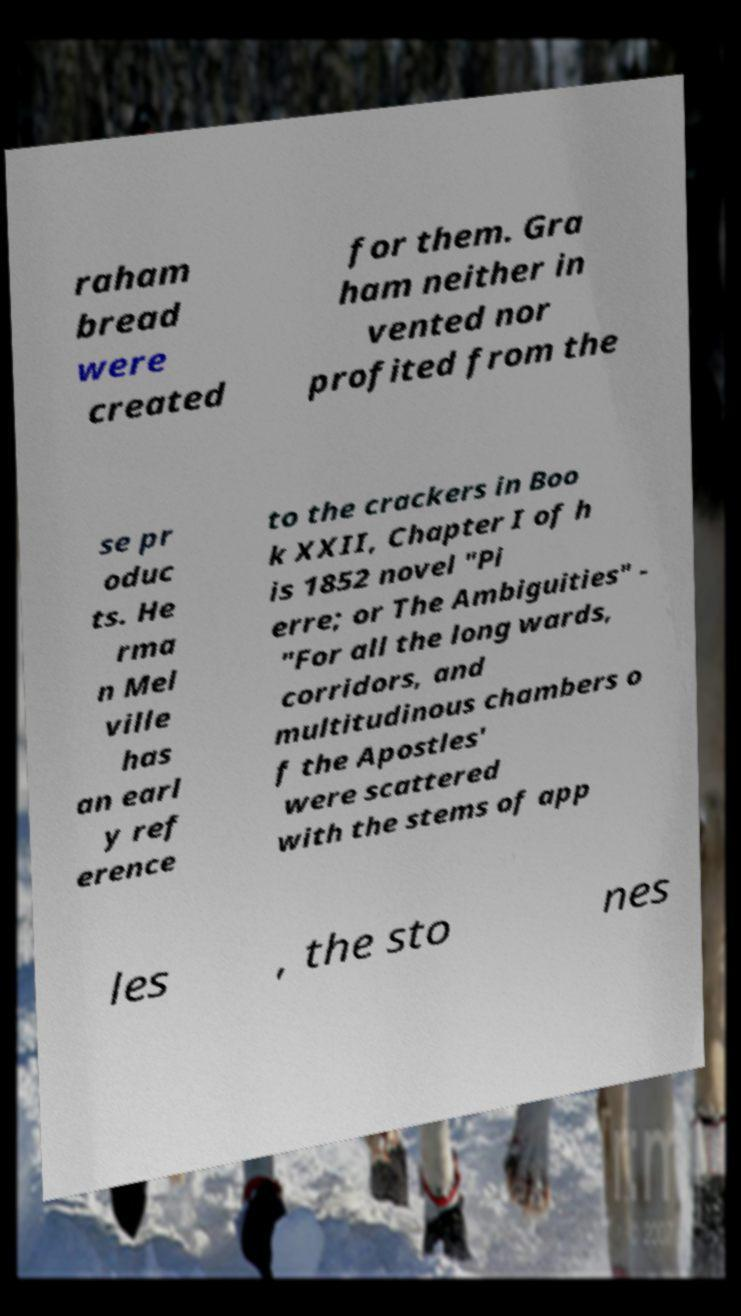Could you assist in decoding the text presented in this image and type it out clearly? raham bread were created for them. Gra ham neither in vented nor profited from the se pr oduc ts. He rma n Mel ville has an earl y ref erence to the crackers in Boo k XXII, Chapter I of h is 1852 novel "Pi erre; or The Ambiguities" - "For all the long wards, corridors, and multitudinous chambers o f the Apostles' were scattered with the stems of app les , the sto nes 